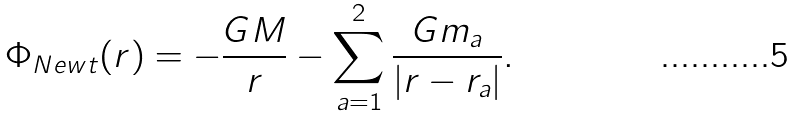<formula> <loc_0><loc_0><loc_500><loc_500>\Phi _ { N e w t } ( { r } ) = - \frac { G M } { r } - \sum _ { a = 1 } ^ { 2 } \frac { G m _ { a } } { | { r } - { r } _ { a } | } .</formula> 